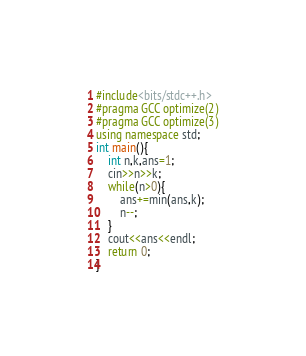<code> <loc_0><loc_0><loc_500><loc_500><_C++_>#include<bits/stdc++.h>
#pragma GCC optimize(2)
#pragma GCC optimize(3)
using namespace std;
int main(){
    int n,k,ans=1;
	cin>>n>>k;
	while(n>0){
		ans+=min(ans,k);
		n--;
	}
	cout<<ans<<endl;
	return 0;
}</code> 